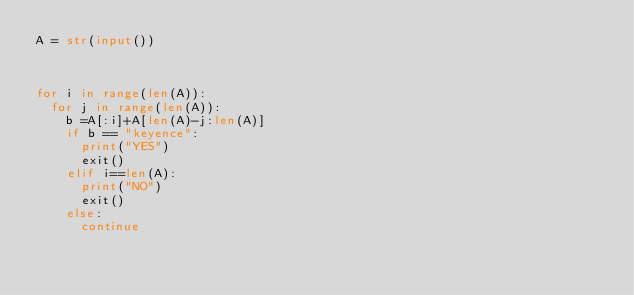<code> <loc_0><loc_0><loc_500><loc_500><_Python_>A = str(input())



for i in range(len(A)):
  for j in range(len(A)):
    b =A[:i]+A[len(A)-j:len(A)]
    if b == "keyence":
      print("YES")
      exit()
    elif i==len(A):
      print("NO")
      exit()
    else:
      continue
</code> 